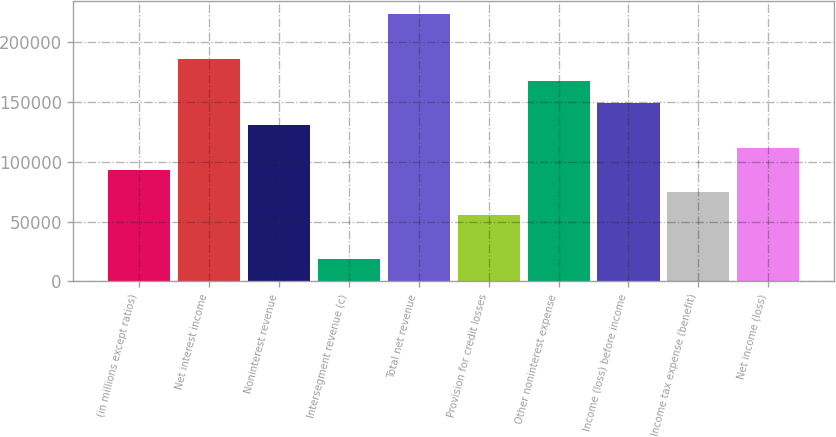Convert chart to OTSL. <chart><loc_0><loc_0><loc_500><loc_500><bar_chart><fcel>(in millions except ratios)<fcel>Net interest income<fcel>Noninterest revenue<fcel>Intersegment revenue (c)<fcel>Total net revenue<fcel>Provision for credit losses<fcel>Other noninterest expense<fcel>Income (loss) before income<fcel>Income tax expense (benefit)<fcel>Net income (loss)<nl><fcel>92976<fcel>185928<fcel>130157<fcel>18614.4<fcel>223109<fcel>55795.2<fcel>167338<fcel>148747<fcel>74385.6<fcel>111566<nl></chart> 